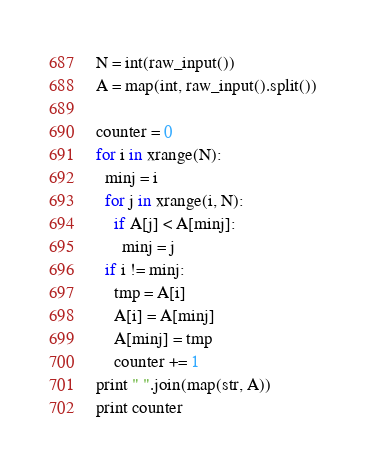<code> <loc_0><loc_0><loc_500><loc_500><_Python_>N = int(raw_input())
A = map(int, raw_input().split())

counter = 0
for i in xrange(N):
  minj = i
  for j in xrange(i, N):
    if A[j] < A[minj]:
      minj = j
  if i != minj:
    tmp = A[i]
    A[i] = A[minj]
    A[minj] = tmp
    counter += 1
print " ".join(map(str, A))
print counter</code> 